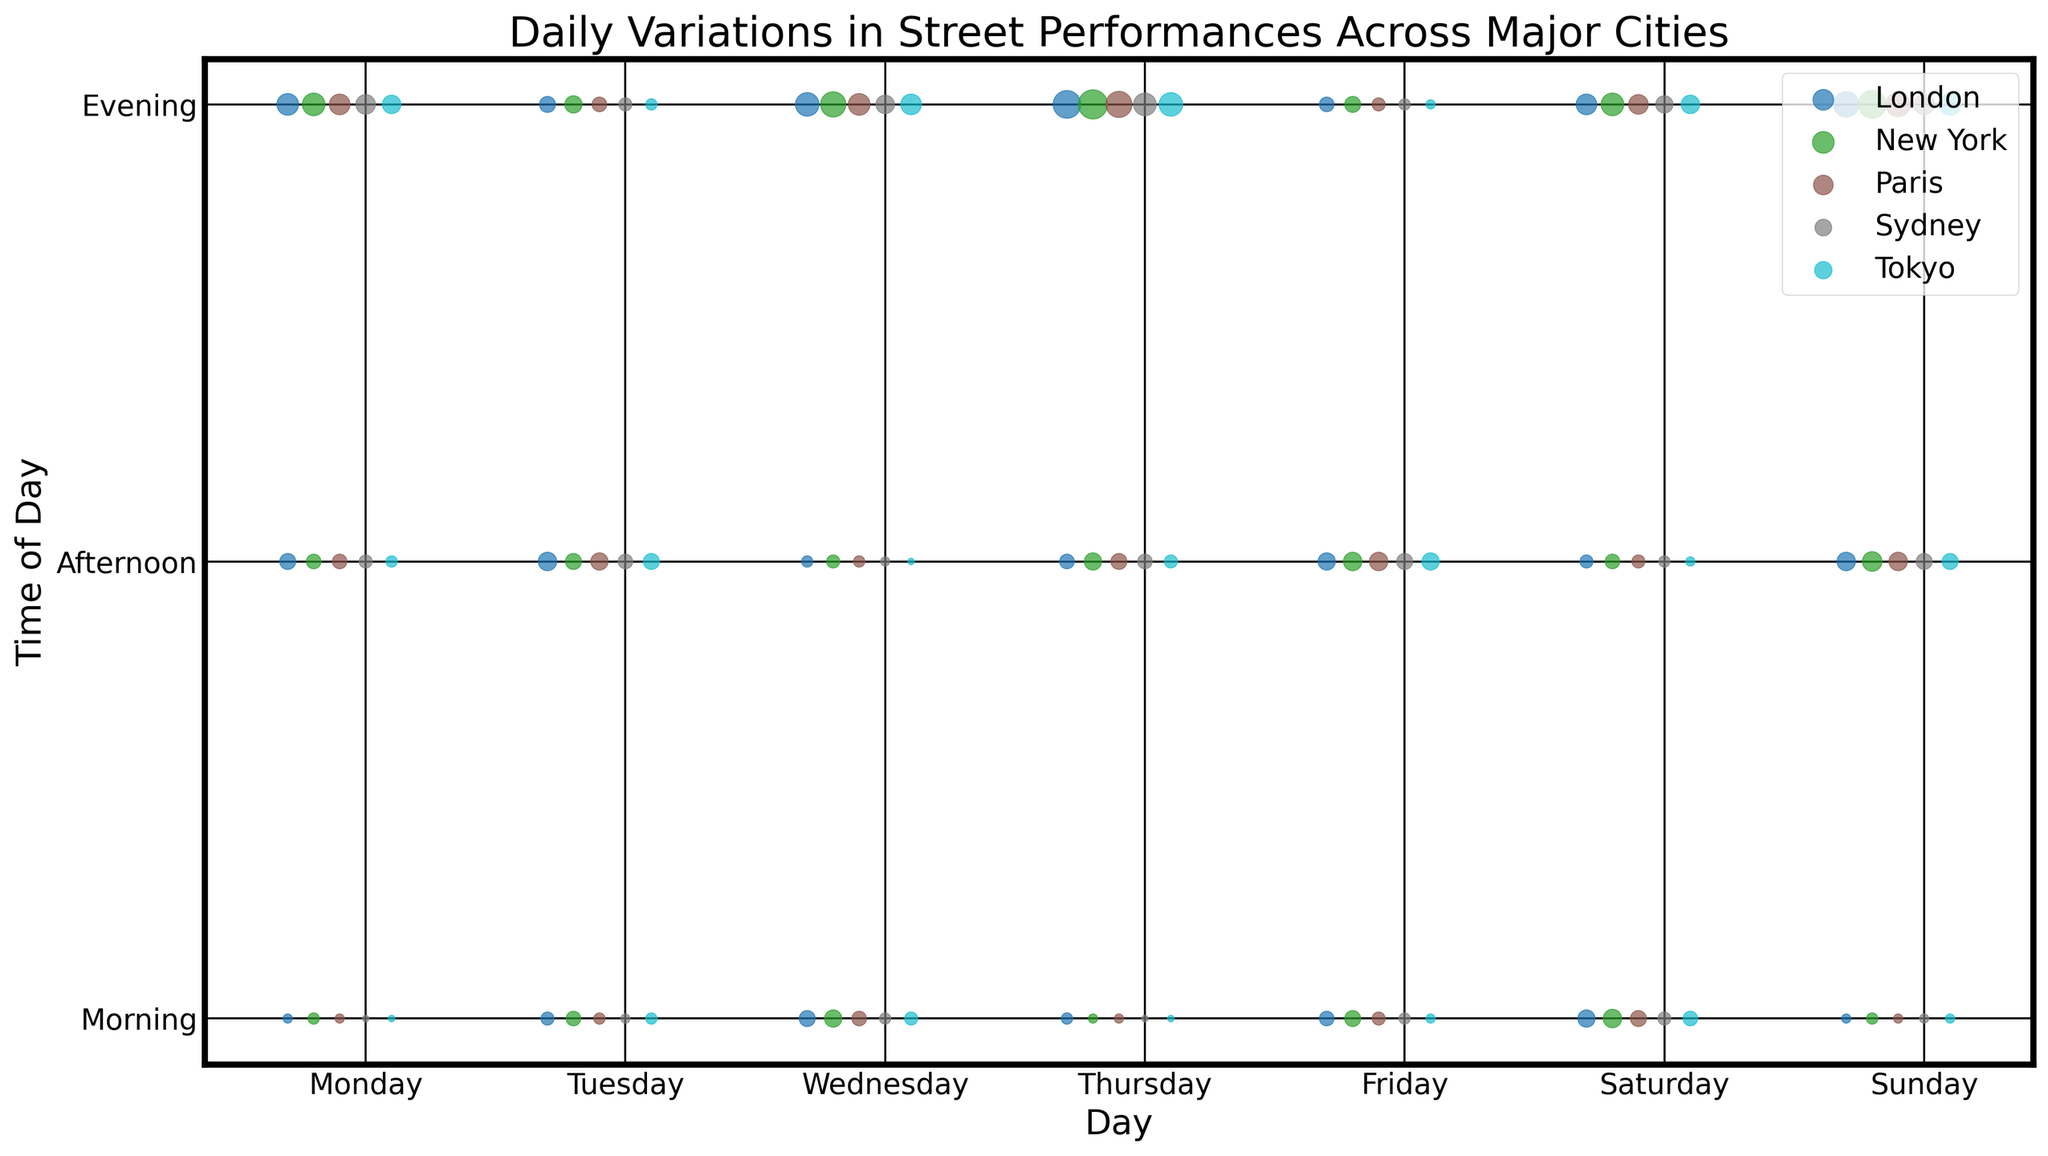Which city has the highest number of evening performances on Saturdays? Look at the scatter plot points for Saturday evenings and compare the sizes of the marks for each city.
Answer: New York Between New York and Tokyo, which city has more street performances overall on weekdays (Monday to Friday)? Sum the number of performances for each city from Monday to Friday. For New York, the total is (3+5+7+2+6+8+3+5+6+4+7+8+5+9+12) = 90. For Tokyo, the total weekday performances are (1+3+4+1+2+5+2+3+6+1+4+7+2+6+8) = 55.
Answer: New York During which part of the day does Paris have the most performances? Compare the sizes of the scatter plot points for Paris across different parts of the day (morning, afternoon, evening). The largest point should indicate the highest number of performances.
Answer: Saturday evening Which city experiences the highest peak in performances during weekend evenings? Focus on the sizes of the scatter plot points for Saturday and Sunday evenings across all cities. Identify the city with the largest mark.
Answer: New York How do the number of morning performances on Sundays compare between Sydney and London? Compare the sizes of the scatter plot points for Sunday mornings for Sydney and London. Sydney has a slightly larger point than London.
Answer: Sydney has more On average, which city shows a greater increase in the number of performances from morning to evening on Friday? Calculate the increase for each city and find the average for all cities. For New York, the increase from morning to evening is 12 - 5 = 7. For Tokyo, it is 8 - 2 = 6. For London, it is 11 - 4 = 7. For Paris, it is 10 - 4 = 6. For Sydney, it is 9 - 3 = 6. Average = (7 + 6 + 7 + 6 + 6) / 5 = 6.4
Answer: 6.4 Which city has the most consistent number of performances throughout the week? Look for the city with scatter plot points of nearly uniform size throughout all days and times.
Answer: Tokyo Between the mornings in New York and Paris, which city has a wider range in the number of performances during weekdays? Identify the highest and lowest morning performance values for New York and Paris, then calculate the range. For New York, the range is (7 - 2) = 5. For Paris, it is (4 - 2) = 2.
Answer: New York Which part of the day tends to have the fewest number of performances across all cities? Compare the sizes of the scatter plot points across morning, afternoon, and evening sections for all cities. Identify the part of the day with consistently smaller points.
Answer: Morning 